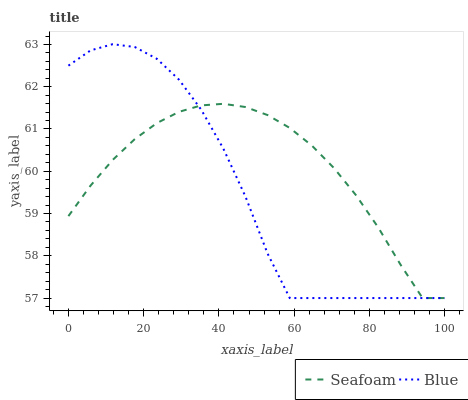Does Blue have the minimum area under the curve?
Answer yes or no. Yes. Does Seafoam have the maximum area under the curve?
Answer yes or no. Yes. Does Seafoam have the minimum area under the curve?
Answer yes or no. No. Is Seafoam the smoothest?
Answer yes or no. Yes. Is Blue the roughest?
Answer yes or no. Yes. Is Seafoam the roughest?
Answer yes or no. No. Does Blue have the highest value?
Answer yes or no. Yes. Does Seafoam have the highest value?
Answer yes or no. No. 